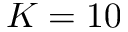<formula> <loc_0><loc_0><loc_500><loc_500>K = 1 0</formula> 